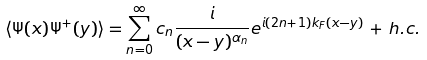<formula> <loc_0><loc_0><loc_500><loc_500>\langle \Psi ( x ) \Psi ^ { + } ( y ) \rangle = \sum _ { n = 0 } ^ { \infty } c _ { n } \frac { i } { ( x - y ) ^ { \alpha _ { n } } } e ^ { i ( 2 n + 1 ) k _ { F } ( x - y ) } \, + \, h . c .</formula> 